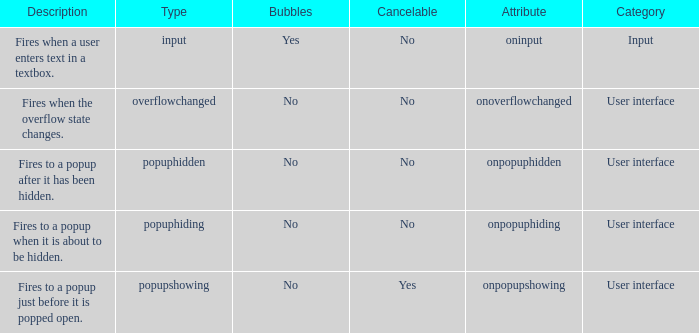What's the attribute with cancelable being yes Onpopupshowing. Can you parse all the data within this table? {'header': ['Description', 'Type', 'Bubbles', 'Cancelable', 'Attribute', 'Category'], 'rows': [['Fires when a user enters text in a textbox.', 'input', 'Yes', 'No', 'oninput', 'Input'], ['Fires when the overflow state changes.', 'overflowchanged', 'No', 'No', 'onoverflowchanged', 'User interface'], ['Fires to a popup after it has been hidden.', 'popuphidden', 'No', 'No', 'onpopuphidden', 'User interface'], ['Fires to a popup when it is about to be hidden.', 'popuphiding', 'No', 'No', 'onpopuphiding', 'User interface'], ['Fires to a popup just before it is popped open.', 'popupshowing', 'No', 'Yes', 'onpopupshowing', 'User interface']]} 